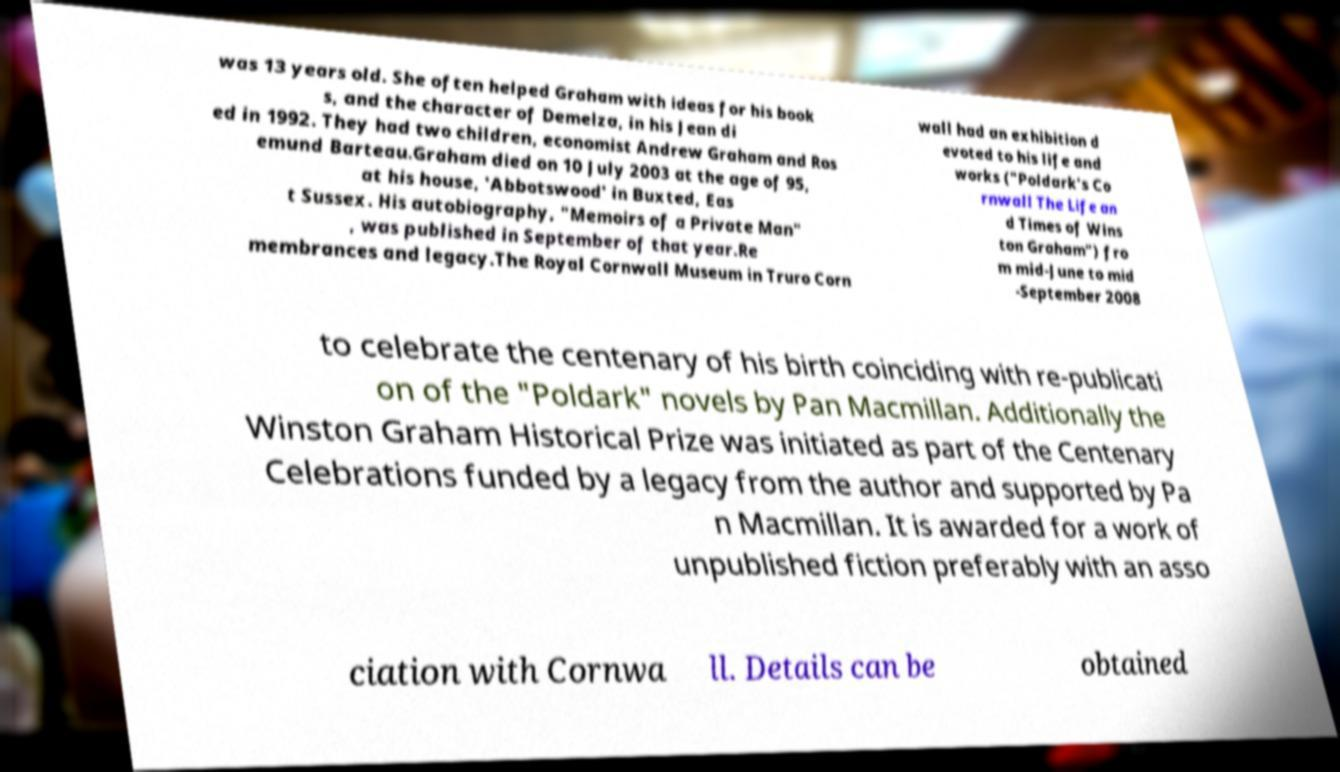There's text embedded in this image that I need extracted. Can you transcribe it verbatim? was 13 years old. She often helped Graham with ideas for his book s, and the character of Demelza, in his Jean di ed in 1992. They had two children, economist Andrew Graham and Ros emund Barteau.Graham died on 10 July 2003 at the age of 95, at his house, 'Abbotswood' in Buxted, Eas t Sussex. His autobiography, "Memoirs of a Private Man" , was published in September of that year.Re membrances and legacy.The Royal Cornwall Museum in Truro Corn wall had an exhibition d evoted to his life and works ("Poldark's Co rnwall The Life an d Times of Wins ton Graham") fro m mid-June to mid -September 2008 to celebrate the centenary of his birth coinciding with re-publicati on of the "Poldark" novels by Pan Macmillan. Additionally the Winston Graham Historical Prize was initiated as part of the Centenary Celebrations funded by a legacy from the author and supported by Pa n Macmillan. It is awarded for a work of unpublished fiction preferably with an asso ciation with Cornwa ll. Details can be obtained 